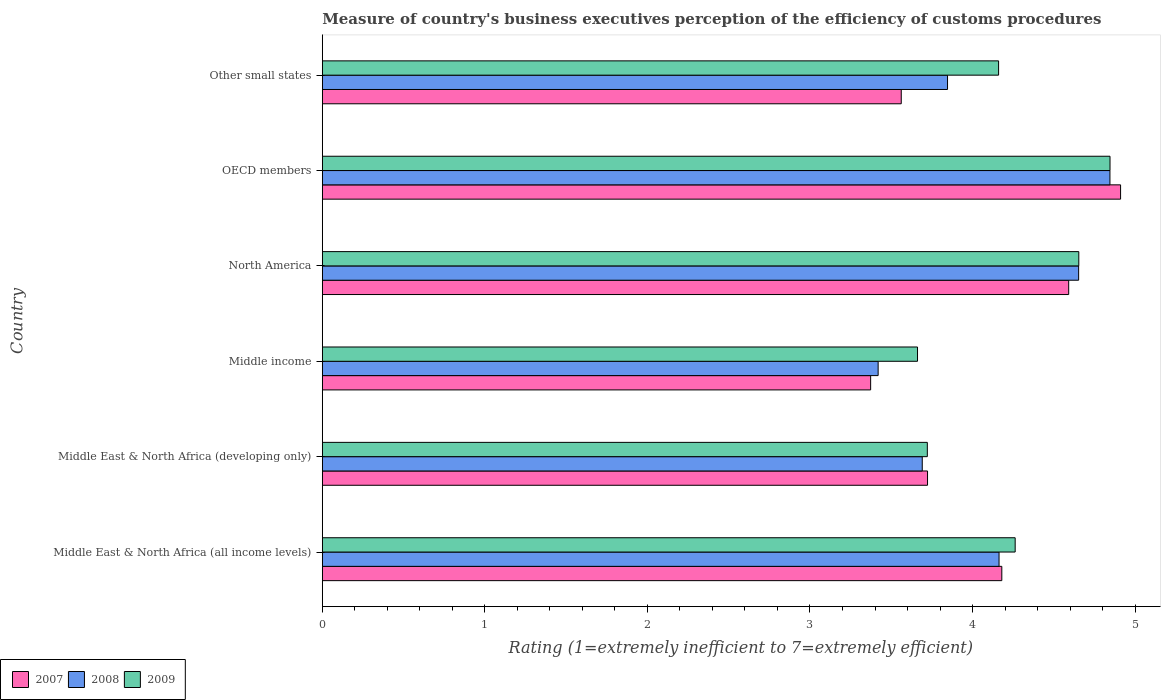How many different coloured bars are there?
Your answer should be compact. 3. How many groups of bars are there?
Keep it short and to the point. 6. Are the number of bars on each tick of the Y-axis equal?
Give a very brief answer. Yes. How many bars are there on the 2nd tick from the top?
Provide a short and direct response. 3. How many bars are there on the 5th tick from the bottom?
Keep it short and to the point. 3. What is the label of the 3rd group of bars from the top?
Keep it short and to the point. North America. What is the rating of the efficiency of customs procedure in 2008 in Middle East & North Africa (all income levels)?
Ensure brevity in your answer.  4.16. Across all countries, what is the maximum rating of the efficiency of customs procedure in 2007?
Give a very brief answer. 4.91. Across all countries, what is the minimum rating of the efficiency of customs procedure in 2007?
Make the answer very short. 3.37. In which country was the rating of the efficiency of customs procedure in 2008 maximum?
Offer a very short reply. OECD members. In which country was the rating of the efficiency of customs procedure in 2007 minimum?
Keep it short and to the point. Middle income. What is the total rating of the efficiency of customs procedure in 2007 in the graph?
Ensure brevity in your answer.  24.34. What is the difference between the rating of the efficiency of customs procedure in 2007 in Middle income and that in North America?
Keep it short and to the point. -1.22. What is the difference between the rating of the efficiency of customs procedure in 2008 in Middle income and the rating of the efficiency of customs procedure in 2007 in Middle East & North Africa (developing only)?
Provide a short and direct response. -0.3. What is the average rating of the efficiency of customs procedure in 2008 per country?
Offer a terse response. 4.1. What is the difference between the rating of the efficiency of customs procedure in 2007 and rating of the efficiency of customs procedure in 2008 in Middle income?
Offer a very short reply. -0.05. What is the ratio of the rating of the efficiency of customs procedure in 2009 in Middle income to that in North America?
Your answer should be very brief. 0.79. Is the rating of the efficiency of customs procedure in 2009 in Middle income less than that in Other small states?
Your response must be concise. Yes. What is the difference between the highest and the second highest rating of the efficiency of customs procedure in 2008?
Provide a short and direct response. 0.19. What is the difference between the highest and the lowest rating of the efficiency of customs procedure in 2009?
Your response must be concise. 1.18. Is the sum of the rating of the efficiency of customs procedure in 2008 in Middle income and North America greater than the maximum rating of the efficiency of customs procedure in 2007 across all countries?
Your answer should be compact. Yes. Is it the case that in every country, the sum of the rating of the efficiency of customs procedure in 2008 and rating of the efficiency of customs procedure in 2009 is greater than the rating of the efficiency of customs procedure in 2007?
Offer a terse response. Yes. Are all the bars in the graph horizontal?
Give a very brief answer. Yes. How many countries are there in the graph?
Ensure brevity in your answer.  6. Are the values on the major ticks of X-axis written in scientific E-notation?
Make the answer very short. No. How are the legend labels stacked?
Offer a very short reply. Horizontal. What is the title of the graph?
Your response must be concise. Measure of country's business executives perception of the efficiency of customs procedures. Does "1978" appear as one of the legend labels in the graph?
Ensure brevity in your answer.  No. What is the label or title of the X-axis?
Give a very brief answer. Rating (1=extremely inefficient to 7=extremely efficient). What is the Rating (1=extremely inefficient to 7=extremely efficient) in 2007 in Middle East & North Africa (all income levels)?
Offer a very short reply. 4.18. What is the Rating (1=extremely inefficient to 7=extremely efficient) of 2008 in Middle East & North Africa (all income levels)?
Ensure brevity in your answer.  4.16. What is the Rating (1=extremely inefficient to 7=extremely efficient) in 2009 in Middle East & North Africa (all income levels)?
Your answer should be compact. 4.26. What is the Rating (1=extremely inefficient to 7=extremely efficient) of 2007 in Middle East & North Africa (developing only)?
Ensure brevity in your answer.  3.72. What is the Rating (1=extremely inefficient to 7=extremely efficient) of 2008 in Middle East & North Africa (developing only)?
Make the answer very short. 3.69. What is the Rating (1=extremely inefficient to 7=extremely efficient) of 2009 in Middle East & North Africa (developing only)?
Provide a short and direct response. 3.72. What is the Rating (1=extremely inefficient to 7=extremely efficient) in 2007 in Middle income?
Keep it short and to the point. 3.37. What is the Rating (1=extremely inefficient to 7=extremely efficient) in 2008 in Middle income?
Give a very brief answer. 3.42. What is the Rating (1=extremely inefficient to 7=extremely efficient) in 2009 in Middle income?
Your response must be concise. 3.66. What is the Rating (1=extremely inefficient to 7=extremely efficient) of 2007 in North America?
Your answer should be very brief. 4.59. What is the Rating (1=extremely inefficient to 7=extremely efficient) of 2008 in North America?
Your answer should be very brief. 4.65. What is the Rating (1=extremely inefficient to 7=extremely efficient) in 2009 in North America?
Give a very brief answer. 4.65. What is the Rating (1=extremely inefficient to 7=extremely efficient) in 2007 in OECD members?
Your response must be concise. 4.91. What is the Rating (1=extremely inefficient to 7=extremely efficient) in 2008 in OECD members?
Your response must be concise. 4.85. What is the Rating (1=extremely inefficient to 7=extremely efficient) of 2009 in OECD members?
Your answer should be compact. 4.85. What is the Rating (1=extremely inefficient to 7=extremely efficient) in 2007 in Other small states?
Give a very brief answer. 3.56. What is the Rating (1=extremely inefficient to 7=extremely efficient) of 2008 in Other small states?
Offer a terse response. 3.85. What is the Rating (1=extremely inefficient to 7=extremely efficient) of 2009 in Other small states?
Keep it short and to the point. 4.16. Across all countries, what is the maximum Rating (1=extremely inefficient to 7=extremely efficient) of 2007?
Your answer should be very brief. 4.91. Across all countries, what is the maximum Rating (1=extremely inefficient to 7=extremely efficient) in 2008?
Keep it short and to the point. 4.85. Across all countries, what is the maximum Rating (1=extremely inefficient to 7=extremely efficient) in 2009?
Offer a very short reply. 4.85. Across all countries, what is the minimum Rating (1=extremely inefficient to 7=extremely efficient) of 2007?
Ensure brevity in your answer.  3.37. Across all countries, what is the minimum Rating (1=extremely inefficient to 7=extremely efficient) of 2008?
Provide a succinct answer. 3.42. Across all countries, what is the minimum Rating (1=extremely inefficient to 7=extremely efficient) in 2009?
Ensure brevity in your answer.  3.66. What is the total Rating (1=extremely inefficient to 7=extremely efficient) of 2007 in the graph?
Ensure brevity in your answer.  24.34. What is the total Rating (1=extremely inefficient to 7=extremely efficient) of 2008 in the graph?
Offer a terse response. 24.62. What is the total Rating (1=extremely inefficient to 7=extremely efficient) in 2009 in the graph?
Provide a short and direct response. 25.31. What is the difference between the Rating (1=extremely inefficient to 7=extremely efficient) in 2007 in Middle East & North Africa (all income levels) and that in Middle East & North Africa (developing only)?
Offer a terse response. 0.46. What is the difference between the Rating (1=extremely inefficient to 7=extremely efficient) in 2008 in Middle East & North Africa (all income levels) and that in Middle East & North Africa (developing only)?
Offer a very short reply. 0.47. What is the difference between the Rating (1=extremely inefficient to 7=extremely efficient) of 2009 in Middle East & North Africa (all income levels) and that in Middle East & North Africa (developing only)?
Offer a very short reply. 0.54. What is the difference between the Rating (1=extremely inefficient to 7=extremely efficient) of 2007 in Middle East & North Africa (all income levels) and that in Middle income?
Ensure brevity in your answer.  0.81. What is the difference between the Rating (1=extremely inefficient to 7=extremely efficient) of 2008 in Middle East & North Africa (all income levels) and that in Middle income?
Make the answer very short. 0.74. What is the difference between the Rating (1=extremely inefficient to 7=extremely efficient) in 2009 in Middle East & North Africa (all income levels) and that in Middle income?
Keep it short and to the point. 0.6. What is the difference between the Rating (1=extremely inefficient to 7=extremely efficient) of 2007 in Middle East & North Africa (all income levels) and that in North America?
Provide a succinct answer. -0.41. What is the difference between the Rating (1=extremely inefficient to 7=extremely efficient) of 2008 in Middle East & North Africa (all income levels) and that in North America?
Keep it short and to the point. -0.49. What is the difference between the Rating (1=extremely inefficient to 7=extremely efficient) in 2009 in Middle East & North Africa (all income levels) and that in North America?
Offer a very short reply. -0.39. What is the difference between the Rating (1=extremely inefficient to 7=extremely efficient) in 2007 in Middle East & North Africa (all income levels) and that in OECD members?
Offer a terse response. -0.73. What is the difference between the Rating (1=extremely inefficient to 7=extremely efficient) in 2008 in Middle East & North Africa (all income levels) and that in OECD members?
Ensure brevity in your answer.  -0.68. What is the difference between the Rating (1=extremely inefficient to 7=extremely efficient) in 2009 in Middle East & North Africa (all income levels) and that in OECD members?
Ensure brevity in your answer.  -0.58. What is the difference between the Rating (1=extremely inefficient to 7=extremely efficient) in 2007 in Middle East & North Africa (all income levels) and that in Other small states?
Offer a very short reply. 0.62. What is the difference between the Rating (1=extremely inefficient to 7=extremely efficient) in 2008 in Middle East & North Africa (all income levels) and that in Other small states?
Offer a very short reply. 0.32. What is the difference between the Rating (1=extremely inefficient to 7=extremely efficient) of 2009 in Middle East & North Africa (all income levels) and that in Other small states?
Offer a very short reply. 0.1. What is the difference between the Rating (1=extremely inefficient to 7=extremely efficient) in 2007 in Middle East & North Africa (developing only) and that in Middle income?
Provide a short and direct response. 0.35. What is the difference between the Rating (1=extremely inefficient to 7=extremely efficient) in 2008 in Middle East & North Africa (developing only) and that in Middle income?
Make the answer very short. 0.27. What is the difference between the Rating (1=extremely inefficient to 7=extremely efficient) of 2009 in Middle East & North Africa (developing only) and that in Middle income?
Ensure brevity in your answer.  0.06. What is the difference between the Rating (1=extremely inefficient to 7=extremely efficient) in 2007 in Middle East & North Africa (developing only) and that in North America?
Give a very brief answer. -0.87. What is the difference between the Rating (1=extremely inefficient to 7=extremely efficient) of 2008 in Middle East & North Africa (developing only) and that in North America?
Ensure brevity in your answer.  -0.96. What is the difference between the Rating (1=extremely inefficient to 7=extremely efficient) of 2009 in Middle East & North Africa (developing only) and that in North America?
Make the answer very short. -0.93. What is the difference between the Rating (1=extremely inefficient to 7=extremely efficient) in 2007 in Middle East & North Africa (developing only) and that in OECD members?
Your answer should be compact. -1.19. What is the difference between the Rating (1=extremely inefficient to 7=extremely efficient) in 2008 in Middle East & North Africa (developing only) and that in OECD members?
Your answer should be compact. -1.15. What is the difference between the Rating (1=extremely inefficient to 7=extremely efficient) in 2009 in Middle East & North Africa (developing only) and that in OECD members?
Make the answer very short. -1.12. What is the difference between the Rating (1=extremely inefficient to 7=extremely efficient) of 2007 in Middle East & North Africa (developing only) and that in Other small states?
Provide a short and direct response. 0.16. What is the difference between the Rating (1=extremely inefficient to 7=extremely efficient) of 2008 in Middle East & North Africa (developing only) and that in Other small states?
Your answer should be compact. -0.16. What is the difference between the Rating (1=extremely inefficient to 7=extremely efficient) in 2009 in Middle East & North Africa (developing only) and that in Other small states?
Provide a short and direct response. -0.44. What is the difference between the Rating (1=extremely inefficient to 7=extremely efficient) in 2007 in Middle income and that in North America?
Your answer should be compact. -1.22. What is the difference between the Rating (1=extremely inefficient to 7=extremely efficient) in 2008 in Middle income and that in North America?
Provide a succinct answer. -1.23. What is the difference between the Rating (1=extremely inefficient to 7=extremely efficient) in 2009 in Middle income and that in North America?
Your answer should be compact. -0.99. What is the difference between the Rating (1=extremely inefficient to 7=extremely efficient) of 2007 in Middle income and that in OECD members?
Your answer should be very brief. -1.54. What is the difference between the Rating (1=extremely inefficient to 7=extremely efficient) in 2008 in Middle income and that in OECD members?
Provide a succinct answer. -1.43. What is the difference between the Rating (1=extremely inefficient to 7=extremely efficient) of 2009 in Middle income and that in OECD members?
Your answer should be very brief. -1.18. What is the difference between the Rating (1=extremely inefficient to 7=extremely efficient) of 2007 in Middle income and that in Other small states?
Ensure brevity in your answer.  -0.19. What is the difference between the Rating (1=extremely inefficient to 7=extremely efficient) of 2008 in Middle income and that in Other small states?
Your response must be concise. -0.43. What is the difference between the Rating (1=extremely inefficient to 7=extremely efficient) in 2009 in Middle income and that in Other small states?
Your answer should be compact. -0.5. What is the difference between the Rating (1=extremely inefficient to 7=extremely efficient) in 2007 in North America and that in OECD members?
Give a very brief answer. -0.32. What is the difference between the Rating (1=extremely inefficient to 7=extremely efficient) of 2008 in North America and that in OECD members?
Your answer should be compact. -0.19. What is the difference between the Rating (1=extremely inefficient to 7=extremely efficient) in 2009 in North America and that in OECD members?
Your answer should be very brief. -0.19. What is the difference between the Rating (1=extremely inefficient to 7=extremely efficient) in 2007 in North America and that in Other small states?
Your answer should be compact. 1.03. What is the difference between the Rating (1=extremely inefficient to 7=extremely efficient) in 2008 in North America and that in Other small states?
Provide a succinct answer. 0.81. What is the difference between the Rating (1=extremely inefficient to 7=extremely efficient) in 2009 in North America and that in Other small states?
Offer a very short reply. 0.49. What is the difference between the Rating (1=extremely inefficient to 7=extremely efficient) of 2007 in OECD members and that in Other small states?
Keep it short and to the point. 1.35. What is the difference between the Rating (1=extremely inefficient to 7=extremely efficient) in 2009 in OECD members and that in Other small states?
Keep it short and to the point. 0.69. What is the difference between the Rating (1=extremely inefficient to 7=extremely efficient) in 2007 in Middle East & North Africa (all income levels) and the Rating (1=extremely inefficient to 7=extremely efficient) in 2008 in Middle East & North Africa (developing only)?
Your answer should be very brief. 0.49. What is the difference between the Rating (1=extremely inefficient to 7=extremely efficient) in 2007 in Middle East & North Africa (all income levels) and the Rating (1=extremely inefficient to 7=extremely efficient) in 2009 in Middle East & North Africa (developing only)?
Offer a terse response. 0.46. What is the difference between the Rating (1=extremely inefficient to 7=extremely efficient) of 2008 in Middle East & North Africa (all income levels) and the Rating (1=extremely inefficient to 7=extremely efficient) of 2009 in Middle East & North Africa (developing only)?
Provide a short and direct response. 0.44. What is the difference between the Rating (1=extremely inefficient to 7=extremely efficient) in 2007 in Middle East & North Africa (all income levels) and the Rating (1=extremely inefficient to 7=extremely efficient) in 2008 in Middle income?
Give a very brief answer. 0.76. What is the difference between the Rating (1=extremely inefficient to 7=extremely efficient) in 2007 in Middle East & North Africa (all income levels) and the Rating (1=extremely inefficient to 7=extremely efficient) in 2009 in Middle income?
Offer a very short reply. 0.52. What is the difference between the Rating (1=extremely inefficient to 7=extremely efficient) in 2008 in Middle East & North Africa (all income levels) and the Rating (1=extremely inefficient to 7=extremely efficient) in 2009 in Middle income?
Your answer should be very brief. 0.5. What is the difference between the Rating (1=extremely inefficient to 7=extremely efficient) of 2007 in Middle East & North Africa (all income levels) and the Rating (1=extremely inefficient to 7=extremely efficient) of 2008 in North America?
Your response must be concise. -0.47. What is the difference between the Rating (1=extremely inefficient to 7=extremely efficient) in 2007 in Middle East & North Africa (all income levels) and the Rating (1=extremely inefficient to 7=extremely efficient) in 2009 in North America?
Offer a very short reply. -0.47. What is the difference between the Rating (1=extremely inefficient to 7=extremely efficient) of 2008 in Middle East & North Africa (all income levels) and the Rating (1=extremely inefficient to 7=extremely efficient) of 2009 in North America?
Your answer should be very brief. -0.49. What is the difference between the Rating (1=extremely inefficient to 7=extremely efficient) in 2007 in Middle East & North Africa (all income levels) and the Rating (1=extremely inefficient to 7=extremely efficient) in 2008 in OECD members?
Make the answer very short. -0.67. What is the difference between the Rating (1=extremely inefficient to 7=extremely efficient) of 2007 in Middle East & North Africa (all income levels) and the Rating (1=extremely inefficient to 7=extremely efficient) of 2009 in OECD members?
Offer a terse response. -0.67. What is the difference between the Rating (1=extremely inefficient to 7=extremely efficient) of 2008 in Middle East & North Africa (all income levels) and the Rating (1=extremely inefficient to 7=extremely efficient) of 2009 in OECD members?
Provide a short and direct response. -0.68. What is the difference between the Rating (1=extremely inefficient to 7=extremely efficient) of 2007 in Middle East & North Africa (all income levels) and the Rating (1=extremely inefficient to 7=extremely efficient) of 2008 in Other small states?
Offer a very short reply. 0.33. What is the difference between the Rating (1=extremely inefficient to 7=extremely efficient) of 2007 in Middle East & North Africa (all income levels) and the Rating (1=extremely inefficient to 7=extremely efficient) of 2009 in Other small states?
Your response must be concise. 0.02. What is the difference between the Rating (1=extremely inefficient to 7=extremely efficient) of 2008 in Middle East & North Africa (all income levels) and the Rating (1=extremely inefficient to 7=extremely efficient) of 2009 in Other small states?
Offer a terse response. 0. What is the difference between the Rating (1=extremely inefficient to 7=extremely efficient) of 2007 in Middle East & North Africa (developing only) and the Rating (1=extremely inefficient to 7=extremely efficient) of 2008 in Middle income?
Ensure brevity in your answer.  0.3. What is the difference between the Rating (1=extremely inefficient to 7=extremely efficient) of 2007 in Middle East & North Africa (developing only) and the Rating (1=extremely inefficient to 7=extremely efficient) of 2009 in Middle income?
Give a very brief answer. 0.06. What is the difference between the Rating (1=extremely inefficient to 7=extremely efficient) in 2008 in Middle East & North Africa (developing only) and the Rating (1=extremely inefficient to 7=extremely efficient) in 2009 in Middle income?
Provide a succinct answer. 0.03. What is the difference between the Rating (1=extremely inefficient to 7=extremely efficient) in 2007 in Middle East & North Africa (developing only) and the Rating (1=extremely inefficient to 7=extremely efficient) in 2008 in North America?
Your answer should be very brief. -0.93. What is the difference between the Rating (1=extremely inefficient to 7=extremely efficient) of 2007 in Middle East & North Africa (developing only) and the Rating (1=extremely inefficient to 7=extremely efficient) of 2009 in North America?
Make the answer very short. -0.93. What is the difference between the Rating (1=extremely inefficient to 7=extremely efficient) in 2008 in Middle East & North Africa (developing only) and the Rating (1=extremely inefficient to 7=extremely efficient) in 2009 in North America?
Keep it short and to the point. -0.96. What is the difference between the Rating (1=extremely inefficient to 7=extremely efficient) of 2007 in Middle East & North Africa (developing only) and the Rating (1=extremely inefficient to 7=extremely efficient) of 2008 in OECD members?
Keep it short and to the point. -1.12. What is the difference between the Rating (1=extremely inefficient to 7=extremely efficient) of 2007 in Middle East & North Africa (developing only) and the Rating (1=extremely inefficient to 7=extremely efficient) of 2009 in OECD members?
Keep it short and to the point. -1.12. What is the difference between the Rating (1=extremely inefficient to 7=extremely efficient) in 2008 in Middle East & North Africa (developing only) and the Rating (1=extremely inefficient to 7=extremely efficient) in 2009 in OECD members?
Offer a very short reply. -1.16. What is the difference between the Rating (1=extremely inefficient to 7=extremely efficient) in 2007 in Middle East & North Africa (developing only) and the Rating (1=extremely inefficient to 7=extremely efficient) in 2008 in Other small states?
Your answer should be very brief. -0.12. What is the difference between the Rating (1=extremely inefficient to 7=extremely efficient) of 2007 in Middle East & North Africa (developing only) and the Rating (1=extremely inefficient to 7=extremely efficient) of 2009 in Other small states?
Provide a short and direct response. -0.44. What is the difference between the Rating (1=extremely inefficient to 7=extremely efficient) of 2008 in Middle East & North Africa (developing only) and the Rating (1=extremely inefficient to 7=extremely efficient) of 2009 in Other small states?
Your answer should be compact. -0.47. What is the difference between the Rating (1=extremely inefficient to 7=extremely efficient) of 2007 in Middle income and the Rating (1=extremely inefficient to 7=extremely efficient) of 2008 in North America?
Your response must be concise. -1.28. What is the difference between the Rating (1=extremely inefficient to 7=extremely efficient) of 2007 in Middle income and the Rating (1=extremely inefficient to 7=extremely efficient) of 2009 in North America?
Provide a short and direct response. -1.28. What is the difference between the Rating (1=extremely inefficient to 7=extremely efficient) of 2008 in Middle income and the Rating (1=extremely inefficient to 7=extremely efficient) of 2009 in North America?
Ensure brevity in your answer.  -1.23. What is the difference between the Rating (1=extremely inefficient to 7=extremely efficient) in 2007 in Middle income and the Rating (1=extremely inefficient to 7=extremely efficient) in 2008 in OECD members?
Your answer should be very brief. -1.47. What is the difference between the Rating (1=extremely inefficient to 7=extremely efficient) of 2007 in Middle income and the Rating (1=extremely inefficient to 7=extremely efficient) of 2009 in OECD members?
Provide a succinct answer. -1.47. What is the difference between the Rating (1=extremely inefficient to 7=extremely efficient) of 2008 in Middle income and the Rating (1=extremely inefficient to 7=extremely efficient) of 2009 in OECD members?
Give a very brief answer. -1.43. What is the difference between the Rating (1=extremely inefficient to 7=extremely efficient) of 2007 in Middle income and the Rating (1=extremely inefficient to 7=extremely efficient) of 2008 in Other small states?
Provide a succinct answer. -0.47. What is the difference between the Rating (1=extremely inefficient to 7=extremely efficient) of 2007 in Middle income and the Rating (1=extremely inefficient to 7=extremely efficient) of 2009 in Other small states?
Give a very brief answer. -0.79. What is the difference between the Rating (1=extremely inefficient to 7=extremely efficient) in 2008 in Middle income and the Rating (1=extremely inefficient to 7=extremely efficient) in 2009 in Other small states?
Provide a short and direct response. -0.74. What is the difference between the Rating (1=extremely inefficient to 7=extremely efficient) of 2007 in North America and the Rating (1=extremely inefficient to 7=extremely efficient) of 2008 in OECD members?
Provide a short and direct response. -0.25. What is the difference between the Rating (1=extremely inefficient to 7=extremely efficient) of 2007 in North America and the Rating (1=extremely inefficient to 7=extremely efficient) of 2009 in OECD members?
Your answer should be very brief. -0.25. What is the difference between the Rating (1=extremely inefficient to 7=extremely efficient) of 2008 in North America and the Rating (1=extremely inefficient to 7=extremely efficient) of 2009 in OECD members?
Offer a very short reply. -0.19. What is the difference between the Rating (1=extremely inefficient to 7=extremely efficient) of 2007 in North America and the Rating (1=extremely inefficient to 7=extremely efficient) of 2008 in Other small states?
Your answer should be very brief. 0.75. What is the difference between the Rating (1=extremely inefficient to 7=extremely efficient) of 2007 in North America and the Rating (1=extremely inefficient to 7=extremely efficient) of 2009 in Other small states?
Your response must be concise. 0.43. What is the difference between the Rating (1=extremely inefficient to 7=extremely efficient) of 2008 in North America and the Rating (1=extremely inefficient to 7=extremely efficient) of 2009 in Other small states?
Your answer should be compact. 0.49. What is the difference between the Rating (1=extremely inefficient to 7=extremely efficient) of 2007 in OECD members and the Rating (1=extremely inefficient to 7=extremely efficient) of 2008 in Other small states?
Your answer should be very brief. 1.06. What is the difference between the Rating (1=extremely inefficient to 7=extremely efficient) of 2007 in OECD members and the Rating (1=extremely inefficient to 7=extremely efficient) of 2009 in Other small states?
Give a very brief answer. 0.75. What is the difference between the Rating (1=extremely inefficient to 7=extremely efficient) in 2008 in OECD members and the Rating (1=extremely inefficient to 7=extremely efficient) in 2009 in Other small states?
Provide a short and direct response. 0.69. What is the average Rating (1=extremely inefficient to 7=extremely efficient) of 2007 per country?
Ensure brevity in your answer.  4.06. What is the average Rating (1=extremely inefficient to 7=extremely efficient) in 2008 per country?
Give a very brief answer. 4.1. What is the average Rating (1=extremely inefficient to 7=extremely efficient) of 2009 per country?
Your answer should be compact. 4.22. What is the difference between the Rating (1=extremely inefficient to 7=extremely efficient) in 2007 and Rating (1=extremely inefficient to 7=extremely efficient) in 2008 in Middle East & North Africa (all income levels)?
Your answer should be compact. 0.02. What is the difference between the Rating (1=extremely inefficient to 7=extremely efficient) of 2007 and Rating (1=extremely inefficient to 7=extremely efficient) of 2009 in Middle East & North Africa (all income levels)?
Your response must be concise. -0.08. What is the difference between the Rating (1=extremely inefficient to 7=extremely efficient) of 2008 and Rating (1=extremely inefficient to 7=extremely efficient) of 2009 in Middle East & North Africa (all income levels)?
Ensure brevity in your answer.  -0.1. What is the difference between the Rating (1=extremely inefficient to 7=extremely efficient) of 2007 and Rating (1=extremely inefficient to 7=extremely efficient) of 2008 in Middle East & North Africa (developing only)?
Offer a very short reply. 0.03. What is the difference between the Rating (1=extremely inefficient to 7=extremely efficient) of 2007 and Rating (1=extremely inefficient to 7=extremely efficient) of 2009 in Middle East & North Africa (developing only)?
Keep it short and to the point. 0. What is the difference between the Rating (1=extremely inefficient to 7=extremely efficient) of 2008 and Rating (1=extremely inefficient to 7=extremely efficient) of 2009 in Middle East & North Africa (developing only)?
Provide a short and direct response. -0.03. What is the difference between the Rating (1=extremely inefficient to 7=extremely efficient) of 2007 and Rating (1=extremely inefficient to 7=extremely efficient) of 2008 in Middle income?
Your answer should be very brief. -0.05. What is the difference between the Rating (1=extremely inefficient to 7=extremely efficient) of 2007 and Rating (1=extremely inefficient to 7=extremely efficient) of 2009 in Middle income?
Offer a terse response. -0.29. What is the difference between the Rating (1=extremely inefficient to 7=extremely efficient) of 2008 and Rating (1=extremely inefficient to 7=extremely efficient) of 2009 in Middle income?
Offer a very short reply. -0.24. What is the difference between the Rating (1=extremely inefficient to 7=extremely efficient) in 2007 and Rating (1=extremely inefficient to 7=extremely efficient) in 2008 in North America?
Ensure brevity in your answer.  -0.06. What is the difference between the Rating (1=extremely inefficient to 7=extremely efficient) of 2007 and Rating (1=extremely inefficient to 7=extremely efficient) of 2009 in North America?
Give a very brief answer. -0.06. What is the difference between the Rating (1=extremely inefficient to 7=extremely efficient) in 2008 and Rating (1=extremely inefficient to 7=extremely efficient) in 2009 in North America?
Provide a short and direct response. -0. What is the difference between the Rating (1=extremely inefficient to 7=extremely efficient) in 2007 and Rating (1=extremely inefficient to 7=extremely efficient) in 2008 in OECD members?
Give a very brief answer. 0.07. What is the difference between the Rating (1=extremely inefficient to 7=extremely efficient) of 2007 and Rating (1=extremely inefficient to 7=extremely efficient) of 2009 in OECD members?
Offer a very short reply. 0.07. What is the difference between the Rating (1=extremely inefficient to 7=extremely efficient) of 2008 and Rating (1=extremely inefficient to 7=extremely efficient) of 2009 in OECD members?
Offer a terse response. -0. What is the difference between the Rating (1=extremely inefficient to 7=extremely efficient) of 2007 and Rating (1=extremely inefficient to 7=extremely efficient) of 2008 in Other small states?
Offer a terse response. -0.28. What is the difference between the Rating (1=extremely inefficient to 7=extremely efficient) in 2007 and Rating (1=extremely inefficient to 7=extremely efficient) in 2009 in Other small states?
Your response must be concise. -0.6. What is the difference between the Rating (1=extremely inefficient to 7=extremely efficient) of 2008 and Rating (1=extremely inefficient to 7=extremely efficient) of 2009 in Other small states?
Provide a short and direct response. -0.31. What is the ratio of the Rating (1=extremely inefficient to 7=extremely efficient) of 2007 in Middle East & North Africa (all income levels) to that in Middle East & North Africa (developing only)?
Provide a succinct answer. 1.12. What is the ratio of the Rating (1=extremely inefficient to 7=extremely efficient) of 2008 in Middle East & North Africa (all income levels) to that in Middle East & North Africa (developing only)?
Offer a very short reply. 1.13. What is the ratio of the Rating (1=extremely inefficient to 7=extremely efficient) in 2009 in Middle East & North Africa (all income levels) to that in Middle East & North Africa (developing only)?
Provide a succinct answer. 1.15. What is the ratio of the Rating (1=extremely inefficient to 7=extremely efficient) in 2007 in Middle East & North Africa (all income levels) to that in Middle income?
Make the answer very short. 1.24. What is the ratio of the Rating (1=extremely inefficient to 7=extremely efficient) in 2008 in Middle East & North Africa (all income levels) to that in Middle income?
Keep it short and to the point. 1.22. What is the ratio of the Rating (1=extremely inefficient to 7=extremely efficient) in 2009 in Middle East & North Africa (all income levels) to that in Middle income?
Provide a short and direct response. 1.16. What is the ratio of the Rating (1=extremely inefficient to 7=extremely efficient) in 2007 in Middle East & North Africa (all income levels) to that in North America?
Provide a short and direct response. 0.91. What is the ratio of the Rating (1=extremely inefficient to 7=extremely efficient) of 2008 in Middle East & North Africa (all income levels) to that in North America?
Your answer should be compact. 0.89. What is the ratio of the Rating (1=extremely inefficient to 7=extremely efficient) in 2009 in Middle East & North Africa (all income levels) to that in North America?
Keep it short and to the point. 0.92. What is the ratio of the Rating (1=extremely inefficient to 7=extremely efficient) in 2007 in Middle East & North Africa (all income levels) to that in OECD members?
Offer a very short reply. 0.85. What is the ratio of the Rating (1=extremely inefficient to 7=extremely efficient) in 2008 in Middle East & North Africa (all income levels) to that in OECD members?
Offer a very short reply. 0.86. What is the ratio of the Rating (1=extremely inefficient to 7=extremely efficient) in 2009 in Middle East & North Africa (all income levels) to that in OECD members?
Offer a terse response. 0.88. What is the ratio of the Rating (1=extremely inefficient to 7=extremely efficient) of 2007 in Middle East & North Africa (all income levels) to that in Other small states?
Make the answer very short. 1.17. What is the ratio of the Rating (1=extremely inefficient to 7=extremely efficient) of 2008 in Middle East & North Africa (all income levels) to that in Other small states?
Your answer should be very brief. 1.08. What is the ratio of the Rating (1=extremely inefficient to 7=extremely efficient) of 2009 in Middle East & North Africa (all income levels) to that in Other small states?
Your answer should be very brief. 1.02. What is the ratio of the Rating (1=extremely inefficient to 7=extremely efficient) of 2007 in Middle East & North Africa (developing only) to that in Middle income?
Your response must be concise. 1.1. What is the ratio of the Rating (1=extremely inefficient to 7=extremely efficient) in 2008 in Middle East & North Africa (developing only) to that in Middle income?
Your answer should be compact. 1.08. What is the ratio of the Rating (1=extremely inefficient to 7=extremely efficient) in 2009 in Middle East & North Africa (developing only) to that in Middle income?
Your answer should be very brief. 1.02. What is the ratio of the Rating (1=extremely inefficient to 7=extremely efficient) in 2007 in Middle East & North Africa (developing only) to that in North America?
Keep it short and to the point. 0.81. What is the ratio of the Rating (1=extremely inefficient to 7=extremely efficient) of 2008 in Middle East & North Africa (developing only) to that in North America?
Offer a very short reply. 0.79. What is the ratio of the Rating (1=extremely inefficient to 7=extremely efficient) of 2009 in Middle East & North Africa (developing only) to that in North America?
Provide a short and direct response. 0.8. What is the ratio of the Rating (1=extremely inefficient to 7=extremely efficient) of 2007 in Middle East & North Africa (developing only) to that in OECD members?
Your answer should be very brief. 0.76. What is the ratio of the Rating (1=extremely inefficient to 7=extremely efficient) of 2008 in Middle East & North Africa (developing only) to that in OECD members?
Offer a very short reply. 0.76. What is the ratio of the Rating (1=extremely inefficient to 7=extremely efficient) of 2009 in Middle East & North Africa (developing only) to that in OECD members?
Offer a very short reply. 0.77. What is the ratio of the Rating (1=extremely inefficient to 7=extremely efficient) in 2007 in Middle East & North Africa (developing only) to that in Other small states?
Your response must be concise. 1.05. What is the ratio of the Rating (1=extremely inefficient to 7=extremely efficient) of 2008 in Middle East & North Africa (developing only) to that in Other small states?
Make the answer very short. 0.96. What is the ratio of the Rating (1=extremely inefficient to 7=extremely efficient) in 2009 in Middle East & North Africa (developing only) to that in Other small states?
Provide a succinct answer. 0.89. What is the ratio of the Rating (1=extremely inefficient to 7=extremely efficient) in 2007 in Middle income to that in North America?
Ensure brevity in your answer.  0.73. What is the ratio of the Rating (1=extremely inefficient to 7=extremely efficient) of 2008 in Middle income to that in North America?
Ensure brevity in your answer.  0.73. What is the ratio of the Rating (1=extremely inefficient to 7=extremely efficient) in 2009 in Middle income to that in North America?
Ensure brevity in your answer.  0.79. What is the ratio of the Rating (1=extremely inefficient to 7=extremely efficient) of 2007 in Middle income to that in OECD members?
Offer a very short reply. 0.69. What is the ratio of the Rating (1=extremely inefficient to 7=extremely efficient) in 2008 in Middle income to that in OECD members?
Ensure brevity in your answer.  0.71. What is the ratio of the Rating (1=extremely inefficient to 7=extremely efficient) in 2009 in Middle income to that in OECD members?
Offer a terse response. 0.76. What is the ratio of the Rating (1=extremely inefficient to 7=extremely efficient) of 2007 in Middle income to that in Other small states?
Give a very brief answer. 0.95. What is the ratio of the Rating (1=extremely inefficient to 7=extremely efficient) in 2008 in Middle income to that in Other small states?
Provide a succinct answer. 0.89. What is the ratio of the Rating (1=extremely inefficient to 7=extremely efficient) in 2009 in Middle income to that in Other small states?
Your response must be concise. 0.88. What is the ratio of the Rating (1=extremely inefficient to 7=extremely efficient) in 2007 in North America to that in OECD members?
Offer a terse response. 0.94. What is the ratio of the Rating (1=extremely inefficient to 7=extremely efficient) in 2008 in North America to that in OECD members?
Your answer should be compact. 0.96. What is the ratio of the Rating (1=extremely inefficient to 7=extremely efficient) of 2009 in North America to that in OECD members?
Provide a succinct answer. 0.96. What is the ratio of the Rating (1=extremely inefficient to 7=extremely efficient) in 2007 in North America to that in Other small states?
Offer a terse response. 1.29. What is the ratio of the Rating (1=extremely inefficient to 7=extremely efficient) of 2008 in North America to that in Other small states?
Your answer should be very brief. 1.21. What is the ratio of the Rating (1=extremely inefficient to 7=extremely efficient) in 2009 in North America to that in Other small states?
Your answer should be compact. 1.12. What is the ratio of the Rating (1=extremely inefficient to 7=extremely efficient) of 2007 in OECD members to that in Other small states?
Your answer should be very brief. 1.38. What is the ratio of the Rating (1=extremely inefficient to 7=extremely efficient) of 2008 in OECD members to that in Other small states?
Ensure brevity in your answer.  1.26. What is the ratio of the Rating (1=extremely inefficient to 7=extremely efficient) in 2009 in OECD members to that in Other small states?
Ensure brevity in your answer.  1.16. What is the difference between the highest and the second highest Rating (1=extremely inefficient to 7=extremely efficient) in 2007?
Offer a terse response. 0.32. What is the difference between the highest and the second highest Rating (1=extremely inefficient to 7=extremely efficient) in 2008?
Provide a short and direct response. 0.19. What is the difference between the highest and the second highest Rating (1=extremely inefficient to 7=extremely efficient) in 2009?
Offer a terse response. 0.19. What is the difference between the highest and the lowest Rating (1=extremely inefficient to 7=extremely efficient) in 2007?
Keep it short and to the point. 1.54. What is the difference between the highest and the lowest Rating (1=extremely inefficient to 7=extremely efficient) in 2008?
Ensure brevity in your answer.  1.43. What is the difference between the highest and the lowest Rating (1=extremely inefficient to 7=extremely efficient) of 2009?
Offer a terse response. 1.18. 